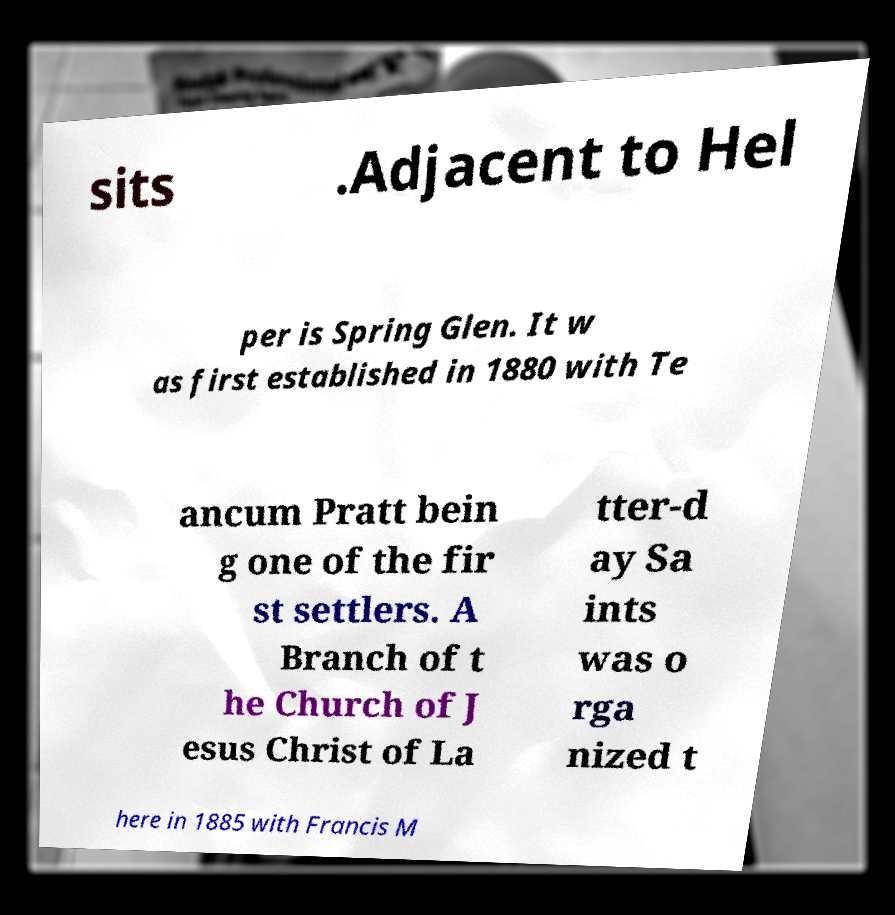Please identify and transcribe the text found in this image. sits .Adjacent to Hel per is Spring Glen. It w as first established in 1880 with Te ancum Pratt bein g one of the fir st settlers. A Branch of t he Church of J esus Christ of La tter-d ay Sa ints was o rga nized t here in 1885 with Francis M 